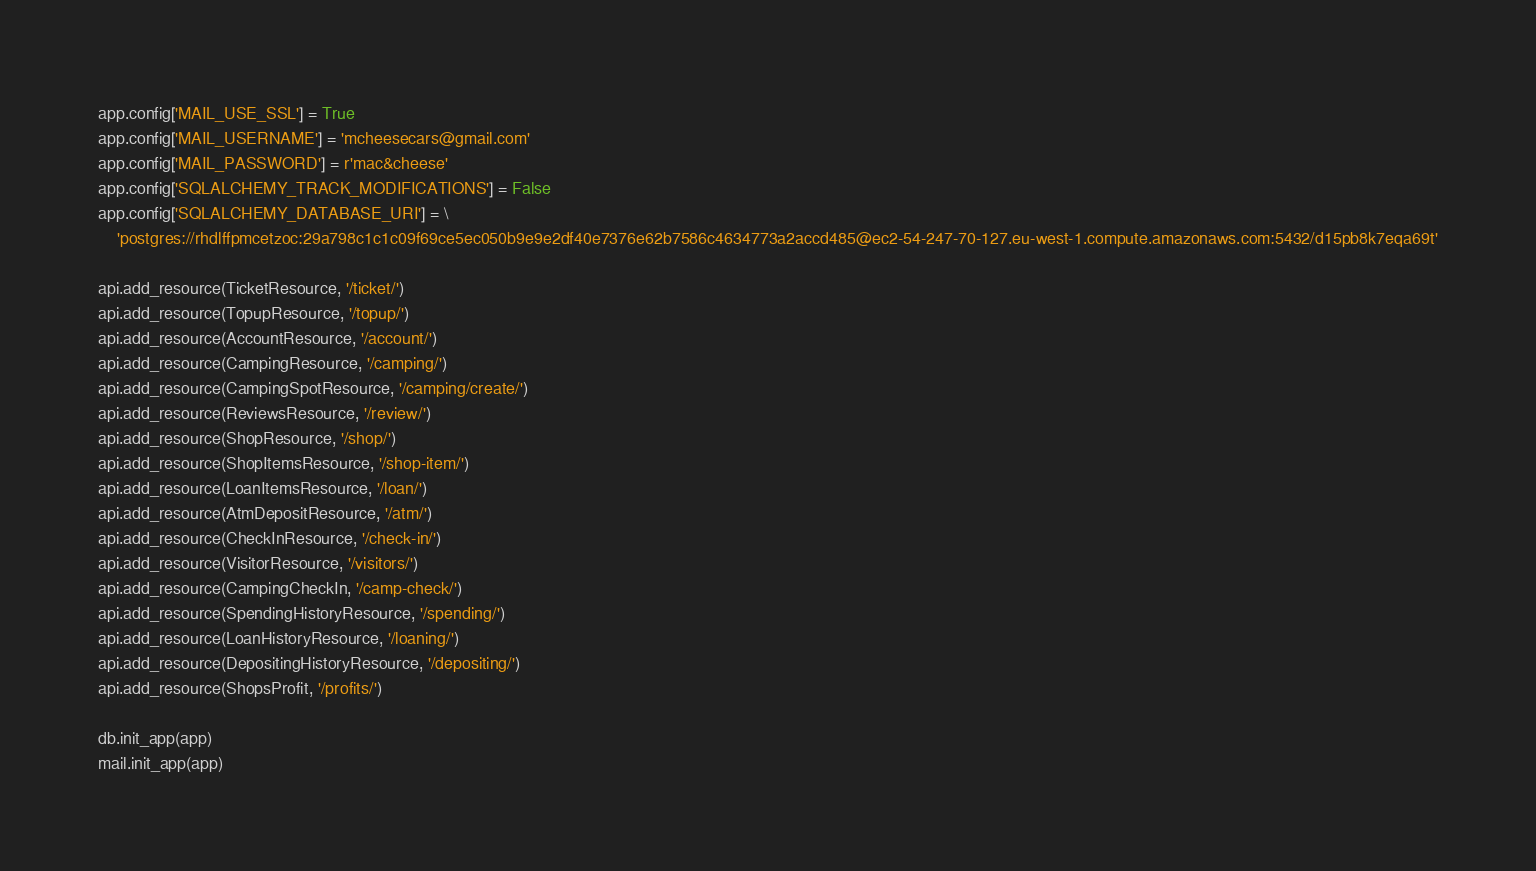<code> <loc_0><loc_0><loc_500><loc_500><_Python_>app.config['MAIL_USE_SSL'] = True
app.config['MAIL_USERNAME'] = 'mcheesecars@gmail.com'
app.config['MAIL_PASSWORD'] = r'mac&cheese'
app.config['SQLALCHEMY_TRACK_MODIFICATIONS'] = False
app.config['SQLALCHEMY_DATABASE_URI'] = \
    'postgres://rhdlffpmcetzoc:29a798c1c1c09f69ce5ec050b9e9e2df40e7376e62b7586c4634773a2accd485@ec2-54-247-70-127.eu-west-1.compute.amazonaws.com:5432/d15pb8k7eqa69t'

api.add_resource(TicketResource, '/ticket/')
api.add_resource(TopupResource, '/topup/')
api.add_resource(AccountResource, '/account/')
api.add_resource(CampingResource, '/camping/')
api.add_resource(CampingSpotResource, '/camping/create/')
api.add_resource(ReviewsResource, '/review/')
api.add_resource(ShopResource, '/shop/')
api.add_resource(ShopItemsResource, '/shop-item/')
api.add_resource(LoanItemsResource, '/loan/')
api.add_resource(AtmDepositResource, '/atm/')
api.add_resource(CheckInResource, '/check-in/')
api.add_resource(VisitorResource, '/visitors/')
api.add_resource(CampingCheckIn, '/camp-check/')
api.add_resource(SpendingHistoryResource, '/spending/')
api.add_resource(LoanHistoryResource, '/loaning/')
api.add_resource(DepositingHistoryResource, '/depositing/')
api.add_resource(ShopsProfit, '/profits/')

db.init_app(app)
mail.init_app(app)
</code> 